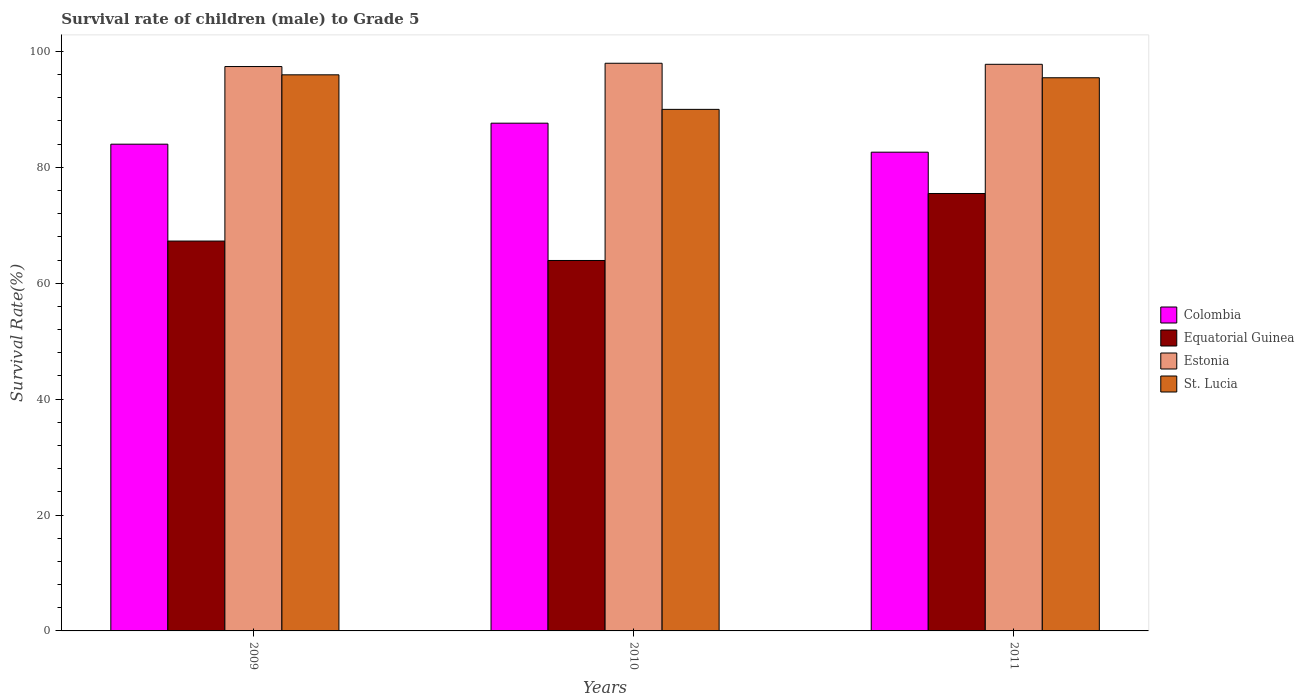How many groups of bars are there?
Your answer should be compact. 3. Are the number of bars per tick equal to the number of legend labels?
Your response must be concise. Yes. What is the survival rate of male children to grade 5 in Colombia in 2011?
Offer a very short reply. 82.61. Across all years, what is the maximum survival rate of male children to grade 5 in Colombia?
Give a very brief answer. 87.62. Across all years, what is the minimum survival rate of male children to grade 5 in Colombia?
Give a very brief answer. 82.61. In which year was the survival rate of male children to grade 5 in Equatorial Guinea maximum?
Keep it short and to the point. 2011. What is the total survival rate of male children to grade 5 in Estonia in the graph?
Provide a short and direct response. 293.13. What is the difference between the survival rate of male children to grade 5 in Estonia in 2010 and that in 2011?
Provide a succinct answer. 0.18. What is the difference between the survival rate of male children to grade 5 in Estonia in 2011 and the survival rate of male children to grade 5 in Equatorial Guinea in 2010?
Offer a terse response. 33.85. What is the average survival rate of male children to grade 5 in Colombia per year?
Your answer should be compact. 84.74. In the year 2009, what is the difference between the survival rate of male children to grade 5 in Colombia and survival rate of male children to grade 5 in St. Lucia?
Ensure brevity in your answer.  -11.97. What is the ratio of the survival rate of male children to grade 5 in Equatorial Guinea in 2009 to that in 2010?
Your answer should be compact. 1.05. Is the survival rate of male children to grade 5 in Colombia in 2009 less than that in 2011?
Provide a short and direct response. No. What is the difference between the highest and the second highest survival rate of male children to grade 5 in Estonia?
Offer a terse response. 0.18. What is the difference between the highest and the lowest survival rate of male children to grade 5 in Estonia?
Offer a terse response. 0.57. In how many years, is the survival rate of male children to grade 5 in Equatorial Guinea greater than the average survival rate of male children to grade 5 in Equatorial Guinea taken over all years?
Your answer should be very brief. 1. What does the 4th bar from the left in 2009 represents?
Keep it short and to the point. St. Lucia. What does the 3rd bar from the right in 2010 represents?
Offer a very short reply. Equatorial Guinea. Is it the case that in every year, the sum of the survival rate of male children to grade 5 in St. Lucia and survival rate of male children to grade 5 in Colombia is greater than the survival rate of male children to grade 5 in Estonia?
Offer a very short reply. Yes. What is the difference between two consecutive major ticks on the Y-axis?
Offer a terse response. 20. Are the values on the major ticks of Y-axis written in scientific E-notation?
Give a very brief answer. No. Does the graph contain any zero values?
Your answer should be compact. No. Does the graph contain grids?
Offer a very short reply. No. Where does the legend appear in the graph?
Offer a very short reply. Center right. What is the title of the graph?
Your answer should be very brief. Survival rate of children (male) to Grade 5. What is the label or title of the Y-axis?
Your response must be concise. Survival Rate(%). What is the Survival Rate(%) of Colombia in 2009?
Your answer should be very brief. 83.99. What is the Survival Rate(%) of Equatorial Guinea in 2009?
Give a very brief answer. 67.27. What is the Survival Rate(%) in Estonia in 2009?
Provide a short and direct response. 97.39. What is the Survival Rate(%) in St. Lucia in 2009?
Your answer should be compact. 95.96. What is the Survival Rate(%) in Colombia in 2010?
Offer a very short reply. 87.62. What is the Survival Rate(%) in Equatorial Guinea in 2010?
Ensure brevity in your answer.  63.92. What is the Survival Rate(%) in Estonia in 2010?
Offer a very short reply. 97.96. What is the Survival Rate(%) in St. Lucia in 2010?
Give a very brief answer. 90. What is the Survival Rate(%) of Colombia in 2011?
Your answer should be compact. 82.61. What is the Survival Rate(%) in Equatorial Guinea in 2011?
Your answer should be very brief. 75.48. What is the Survival Rate(%) in Estonia in 2011?
Make the answer very short. 97.78. What is the Survival Rate(%) of St. Lucia in 2011?
Ensure brevity in your answer.  95.45. Across all years, what is the maximum Survival Rate(%) of Colombia?
Make the answer very short. 87.62. Across all years, what is the maximum Survival Rate(%) of Equatorial Guinea?
Offer a very short reply. 75.48. Across all years, what is the maximum Survival Rate(%) in Estonia?
Your answer should be very brief. 97.96. Across all years, what is the maximum Survival Rate(%) of St. Lucia?
Keep it short and to the point. 95.96. Across all years, what is the minimum Survival Rate(%) in Colombia?
Keep it short and to the point. 82.61. Across all years, what is the minimum Survival Rate(%) in Equatorial Guinea?
Give a very brief answer. 63.92. Across all years, what is the minimum Survival Rate(%) of Estonia?
Offer a terse response. 97.39. Across all years, what is the minimum Survival Rate(%) in St. Lucia?
Offer a terse response. 90. What is the total Survival Rate(%) in Colombia in the graph?
Ensure brevity in your answer.  254.22. What is the total Survival Rate(%) in Equatorial Guinea in the graph?
Offer a terse response. 206.68. What is the total Survival Rate(%) in Estonia in the graph?
Your answer should be compact. 293.13. What is the total Survival Rate(%) of St. Lucia in the graph?
Keep it short and to the point. 281.42. What is the difference between the Survival Rate(%) in Colombia in 2009 and that in 2010?
Provide a short and direct response. -3.62. What is the difference between the Survival Rate(%) in Equatorial Guinea in 2009 and that in 2010?
Give a very brief answer. 3.35. What is the difference between the Survival Rate(%) of Estonia in 2009 and that in 2010?
Give a very brief answer. -0.57. What is the difference between the Survival Rate(%) in St. Lucia in 2009 and that in 2010?
Keep it short and to the point. 5.96. What is the difference between the Survival Rate(%) of Colombia in 2009 and that in 2011?
Keep it short and to the point. 1.38. What is the difference between the Survival Rate(%) in Equatorial Guinea in 2009 and that in 2011?
Offer a terse response. -8.21. What is the difference between the Survival Rate(%) in Estonia in 2009 and that in 2011?
Ensure brevity in your answer.  -0.39. What is the difference between the Survival Rate(%) of St. Lucia in 2009 and that in 2011?
Keep it short and to the point. 0.51. What is the difference between the Survival Rate(%) of Colombia in 2010 and that in 2011?
Your answer should be very brief. 5. What is the difference between the Survival Rate(%) of Equatorial Guinea in 2010 and that in 2011?
Keep it short and to the point. -11.56. What is the difference between the Survival Rate(%) in Estonia in 2010 and that in 2011?
Keep it short and to the point. 0.18. What is the difference between the Survival Rate(%) of St. Lucia in 2010 and that in 2011?
Provide a succinct answer. -5.45. What is the difference between the Survival Rate(%) in Colombia in 2009 and the Survival Rate(%) in Equatorial Guinea in 2010?
Your response must be concise. 20.07. What is the difference between the Survival Rate(%) of Colombia in 2009 and the Survival Rate(%) of Estonia in 2010?
Make the answer very short. -13.96. What is the difference between the Survival Rate(%) in Colombia in 2009 and the Survival Rate(%) in St. Lucia in 2010?
Your response must be concise. -6.01. What is the difference between the Survival Rate(%) in Equatorial Guinea in 2009 and the Survival Rate(%) in Estonia in 2010?
Ensure brevity in your answer.  -30.68. What is the difference between the Survival Rate(%) in Equatorial Guinea in 2009 and the Survival Rate(%) in St. Lucia in 2010?
Your answer should be very brief. -22.73. What is the difference between the Survival Rate(%) in Estonia in 2009 and the Survival Rate(%) in St. Lucia in 2010?
Provide a short and direct response. 7.39. What is the difference between the Survival Rate(%) of Colombia in 2009 and the Survival Rate(%) of Equatorial Guinea in 2011?
Make the answer very short. 8.51. What is the difference between the Survival Rate(%) in Colombia in 2009 and the Survival Rate(%) in Estonia in 2011?
Offer a terse response. -13.79. What is the difference between the Survival Rate(%) in Colombia in 2009 and the Survival Rate(%) in St. Lucia in 2011?
Offer a terse response. -11.46. What is the difference between the Survival Rate(%) in Equatorial Guinea in 2009 and the Survival Rate(%) in Estonia in 2011?
Your response must be concise. -30.5. What is the difference between the Survival Rate(%) of Equatorial Guinea in 2009 and the Survival Rate(%) of St. Lucia in 2011?
Provide a short and direct response. -28.18. What is the difference between the Survival Rate(%) of Estonia in 2009 and the Survival Rate(%) of St. Lucia in 2011?
Ensure brevity in your answer.  1.94. What is the difference between the Survival Rate(%) in Colombia in 2010 and the Survival Rate(%) in Equatorial Guinea in 2011?
Your response must be concise. 12.13. What is the difference between the Survival Rate(%) of Colombia in 2010 and the Survival Rate(%) of Estonia in 2011?
Make the answer very short. -10.16. What is the difference between the Survival Rate(%) in Colombia in 2010 and the Survival Rate(%) in St. Lucia in 2011?
Provide a succinct answer. -7.84. What is the difference between the Survival Rate(%) in Equatorial Guinea in 2010 and the Survival Rate(%) in Estonia in 2011?
Provide a succinct answer. -33.85. What is the difference between the Survival Rate(%) of Equatorial Guinea in 2010 and the Survival Rate(%) of St. Lucia in 2011?
Your answer should be very brief. -31.53. What is the difference between the Survival Rate(%) in Estonia in 2010 and the Survival Rate(%) in St. Lucia in 2011?
Provide a short and direct response. 2.5. What is the average Survival Rate(%) of Colombia per year?
Your answer should be compact. 84.74. What is the average Survival Rate(%) in Equatorial Guinea per year?
Ensure brevity in your answer.  68.89. What is the average Survival Rate(%) in Estonia per year?
Give a very brief answer. 97.71. What is the average Survival Rate(%) of St. Lucia per year?
Offer a terse response. 93.81. In the year 2009, what is the difference between the Survival Rate(%) of Colombia and Survival Rate(%) of Equatorial Guinea?
Give a very brief answer. 16.72. In the year 2009, what is the difference between the Survival Rate(%) of Colombia and Survival Rate(%) of Estonia?
Your response must be concise. -13.4. In the year 2009, what is the difference between the Survival Rate(%) in Colombia and Survival Rate(%) in St. Lucia?
Provide a succinct answer. -11.97. In the year 2009, what is the difference between the Survival Rate(%) of Equatorial Guinea and Survival Rate(%) of Estonia?
Your answer should be compact. -30.12. In the year 2009, what is the difference between the Survival Rate(%) in Equatorial Guinea and Survival Rate(%) in St. Lucia?
Provide a short and direct response. -28.69. In the year 2009, what is the difference between the Survival Rate(%) in Estonia and Survival Rate(%) in St. Lucia?
Offer a very short reply. 1.43. In the year 2010, what is the difference between the Survival Rate(%) in Colombia and Survival Rate(%) in Equatorial Guinea?
Your answer should be very brief. 23.69. In the year 2010, what is the difference between the Survival Rate(%) in Colombia and Survival Rate(%) in Estonia?
Make the answer very short. -10.34. In the year 2010, what is the difference between the Survival Rate(%) of Colombia and Survival Rate(%) of St. Lucia?
Make the answer very short. -2.38. In the year 2010, what is the difference between the Survival Rate(%) of Equatorial Guinea and Survival Rate(%) of Estonia?
Your answer should be very brief. -34.03. In the year 2010, what is the difference between the Survival Rate(%) of Equatorial Guinea and Survival Rate(%) of St. Lucia?
Your response must be concise. -26.08. In the year 2010, what is the difference between the Survival Rate(%) of Estonia and Survival Rate(%) of St. Lucia?
Your response must be concise. 7.96. In the year 2011, what is the difference between the Survival Rate(%) in Colombia and Survival Rate(%) in Equatorial Guinea?
Offer a terse response. 7.13. In the year 2011, what is the difference between the Survival Rate(%) in Colombia and Survival Rate(%) in Estonia?
Offer a very short reply. -15.17. In the year 2011, what is the difference between the Survival Rate(%) in Colombia and Survival Rate(%) in St. Lucia?
Offer a terse response. -12.84. In the year 2011, what is the difference between the Survival Rate(%) of Equatorial Guinea and Survival Rate(%) of Estonia?
Make the answer very short. -22.3. In the year 2011, what is the difference between the Survival Rate(%) of Equatorial Guinea and Survival Rate(%) of St. Lucia?
Give a very brief answer. -19.97. In the year 2011, what is the difference between the Survival Rate(%) of Estonia and Survival Rate(%) of St. Lucia?
Offer a very short reply. 2.32. What is the ratio of the Survival Rate(%) in Colombia in 2009 to that in 2010?
Provide a succinct answer. 0.96. What is the ratio of the Survival Rate(%) in Equatorial Guinea in 2009 to that in 2010?
Make the answer very short. 1.05. What is the ratio of the Survival Rate(%) of St. Lucia in 2009 to that in 2010?
Give a very brief answer. 1.07. What is the ratio of the Survival Rate(%) of Colombia in 2009 to that in 2011?
Give a very brief answer. 1.02. What is the ratio of the Survival Rate(%) in Equatorial Guinea in 2009 to that in 2011?
Provide a short and direct response. 0.89. What is the ratio of the Survival Rate(%) in Estonia in 2009 to that in 2011?
Provide a succinct answer. 1. What is the ratio of the Survival Rate(%) in St. Lucia in 2009 to that in 2011?
Offer a terse response. 1.01. What is the ratio of the Survival Rate(%) in Colombia in 2010 to that in 2011?
Your answer should be very brief. 1.06. What is the ratio of the Survival Rate(%) of Equatorial Guinea in 2010 to that in 2011?
Provide a succinct answer. 0.85. What is the ratio of the Survival Rate(%) in Estonia in 2010 to that in 2011?
Give a very brief answer. 1. What is the ratio of the Survival Rate(%) in St. Lucia in 2010 to that in 2011?
Offer a terse response. 0.94. What is the difference between the highest and the second highest Survival Rate(%) in Colombia?
Provide a short and direct response. 3.62. What is the difference between the highest and the second highest Survival Rate(%) of Equatorial Guinea?
Offer a terse response. 8.21. What is the difference between the highest and the second highest Survival Rate(%) in Estonia?
Provide a short and direct response. 0.18. What is the difference between the highest and the second highest Survival Rate(%) in St. Lucia?
Ensure brevity in your answer.  0.51. What is the difference between the highest and the lowest Survival Rate(%) of Colombia?
Provide a short and direct response. 5. What is the difference between the highest and the lowest Survival Rate(%) in Equatorial Guinea?
Your response must be concise. 11.56. What is the difference between the highest and the lowest Survival Rate(%) in Estonia?
Your answer should be compact. 0.57. What is the difference between the highest and the lowest Survival Rate(%) in St. Lucia?
Keep it short and to the point. 5.96. 